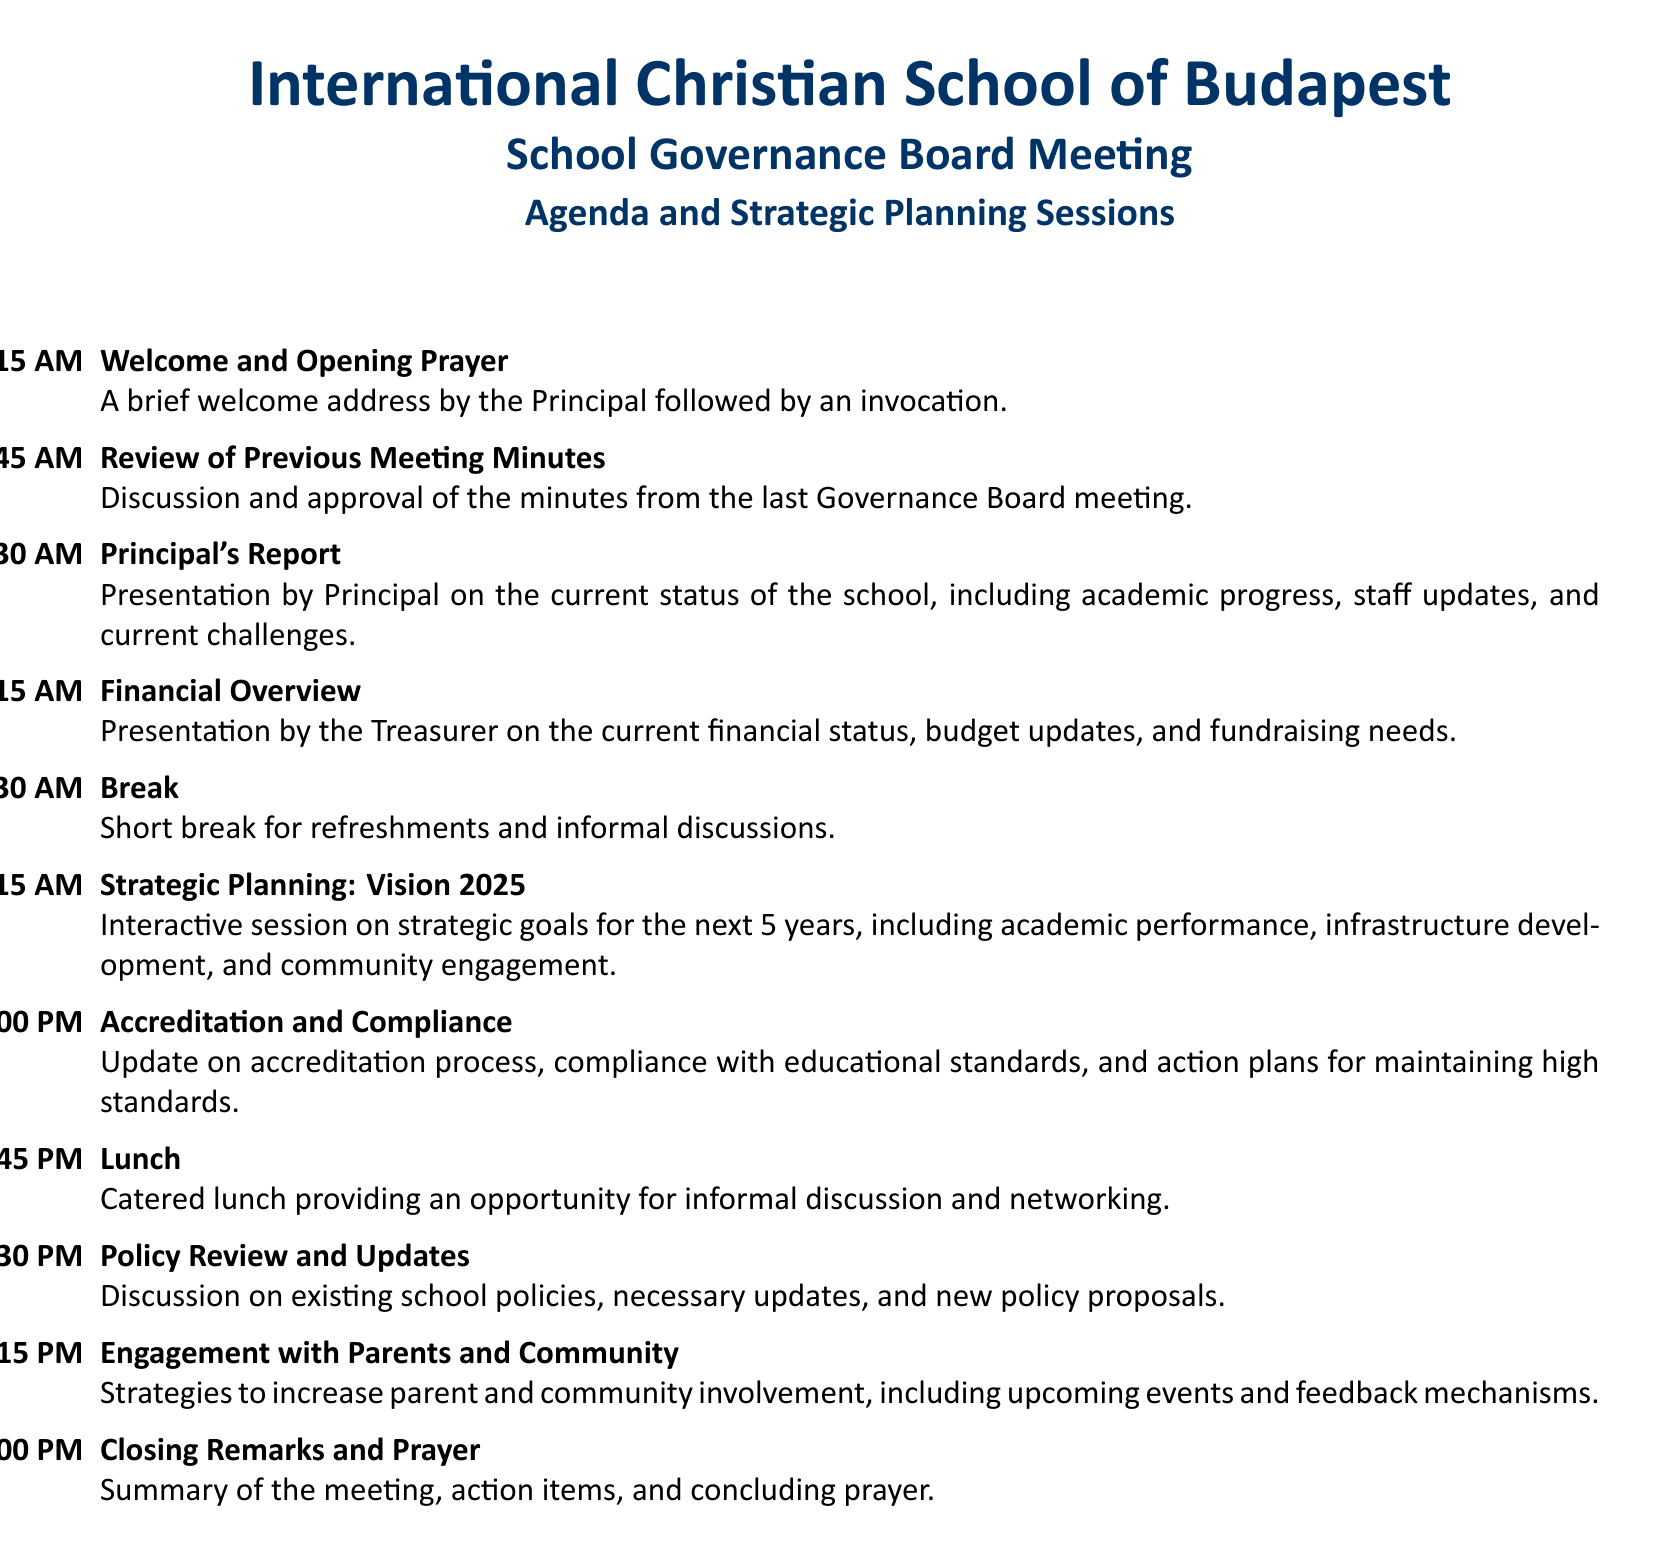What is the start time of the meeting? The meeting starts at 8:00 AM as listed in the agenda.
Answer: 8:00 AM Who presents the financial overview? The Treasurer is responsible for presenting the financial overview during the meeting.
Answer: Treasurer What is the duration of the break? The break lasts for 15 minutes, from 10:15 AM to 10:30 AM.
Answer: 15 minutes What is the main focus of the session titled "Strategic Planning: Vision 2025"? This session focuses on setting strategic goals for the next 5 years.
Answer: Strategic goals How many sessions are scheduled before lunch? There are 6 sessions scheduled before lunch at 12:00 PM.
Answer: 6 sessions What is discussed during the "Policy Review and Updates" session? This session discusses existing school policies and necessary updates.
Answer: Existing school policies How long is the "Principal's Report"? The "Principal's Report" lasts for 45 minutes from 8:45 AM to 9:30 AM.
Answer: 45 minutes What is the concluding action of the meeting? The concluding action is a prayer following the closing remarks.
Answer: Prayer What time does the meeting adjourn? The meeting adjourns after the "Closing Remarks and Prayer" session at 3:00 PM.
Answer: 3:00 PM 